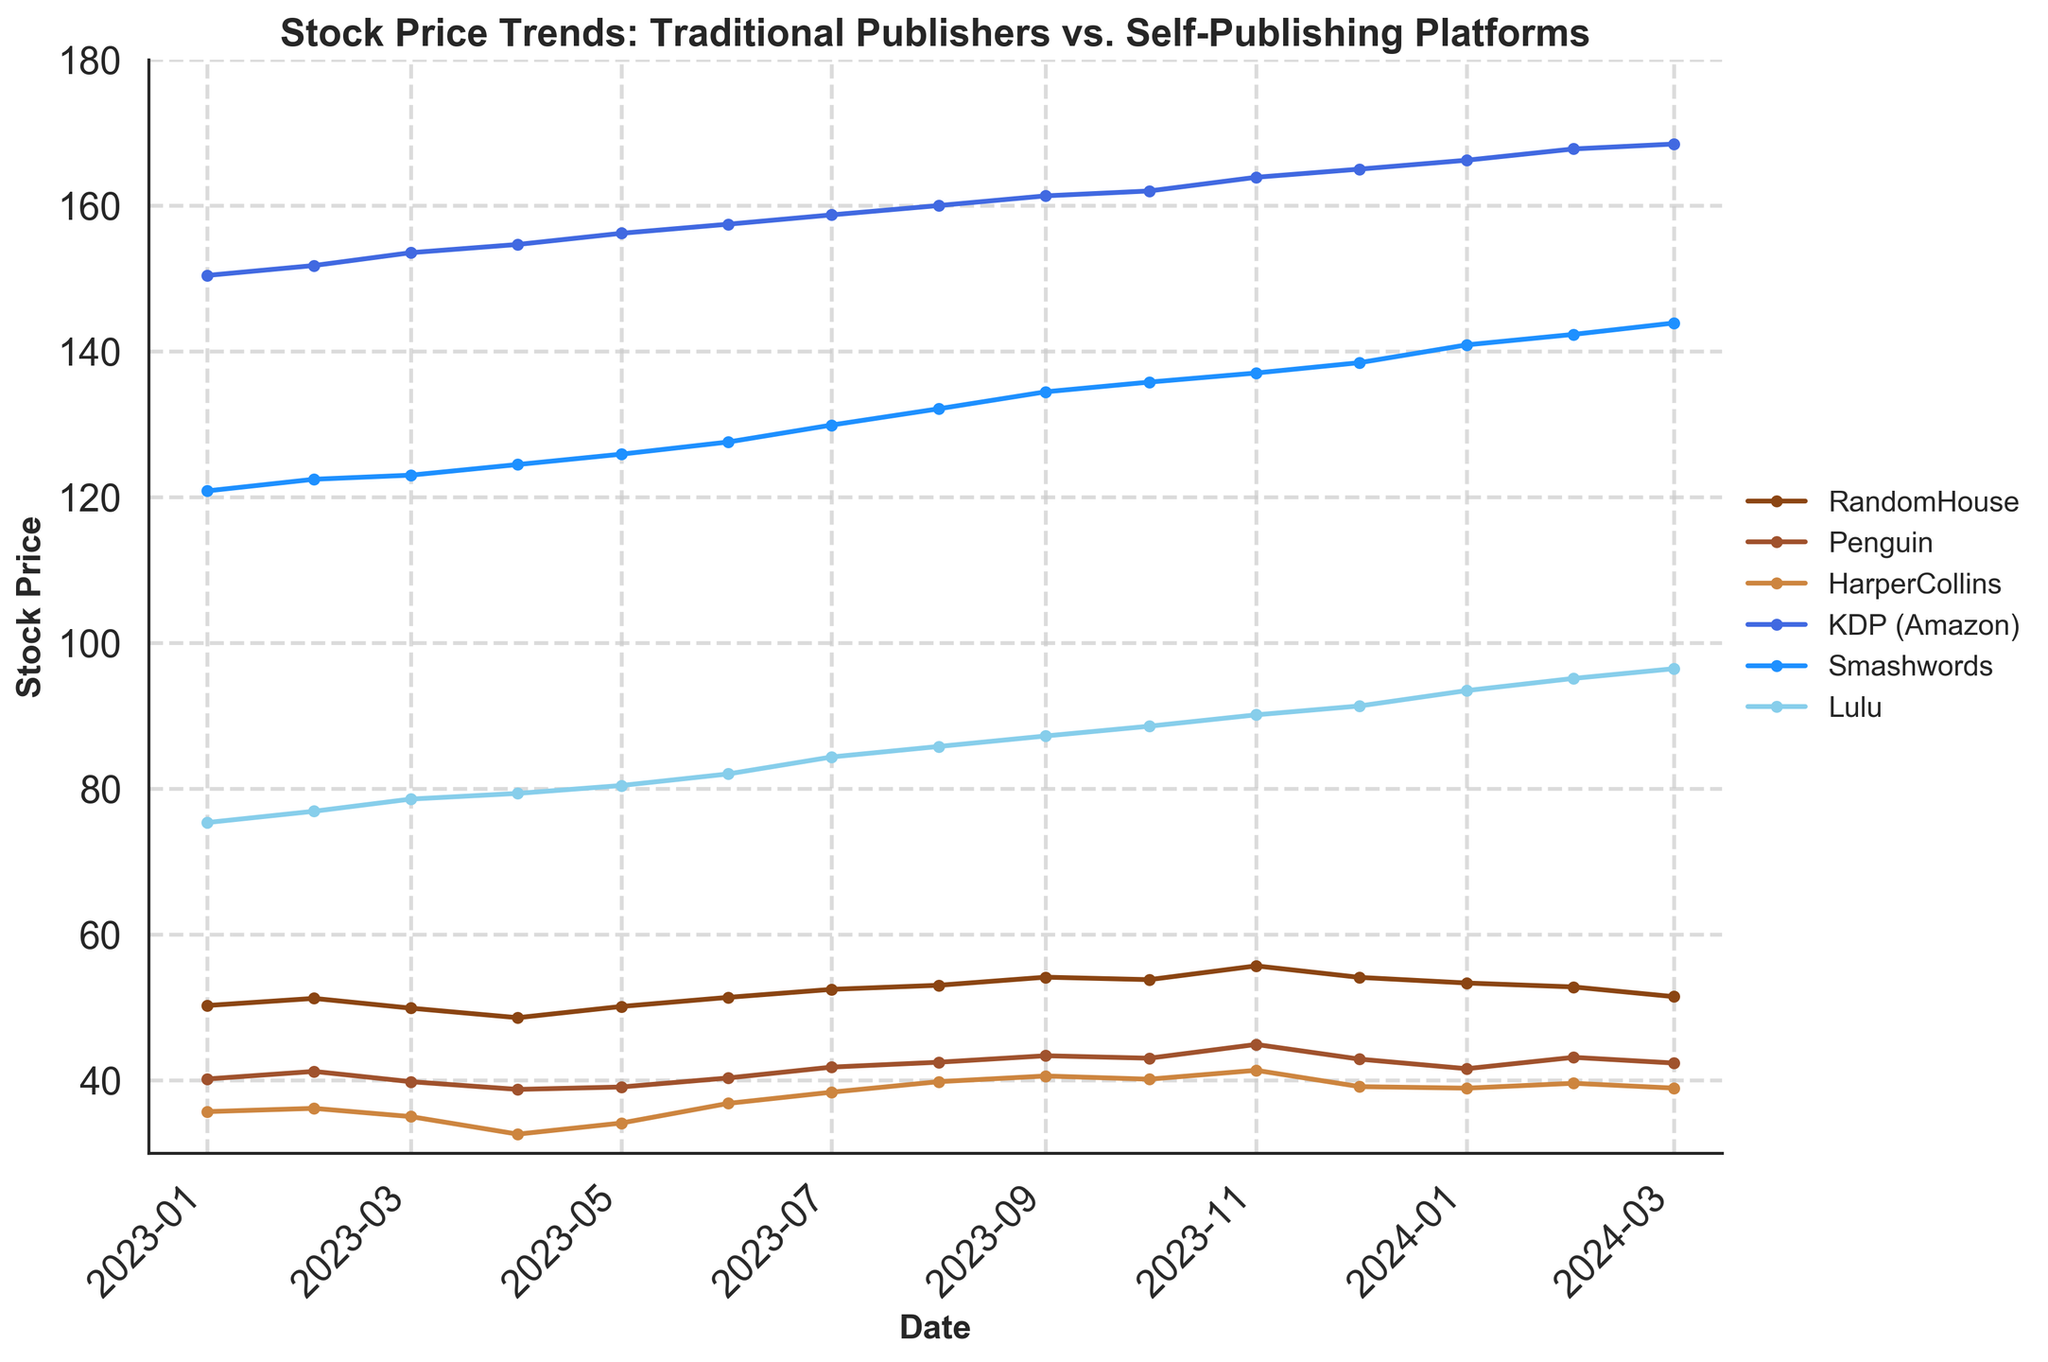What's the title of the plot? The title of the plot is at the top of the chart and provides a summary of what the plot is about.
Answer: Stock Price Trends: Traditional Publishers vs. Self-Publishing Platforms How many companies are represented in the plot? The plot legend on the right side lists all the companies whose stock prices are represented.
Answer: 6 Which company had the highest stock price on 2023-01-01? By examining the y-values of the data points for each company on 2023-01-01, we see that 'KDP (Amazon)' has the highest stock price.
Answer: KDP (Amazon) What general trend is noticeable in the stock prices of 'RandomHouse' and 'Penguin' over the time period? The stock prices for both 'RandomHouse' and 'Penguin' can be seen increasing, which is evident from their series of upward sloping data points.
Answer: Increasing What is the approximate difference in the stock prices of 'HarperCollins' between 2023-03-01 and 2024-03-01? To find the difference, look at the y-values corresponding to these dates and subtract the earlier value from the later one. Stock price on 2023-03-01 is approximately 34.99 and on 2024-03-01 it's about 38.9. So the difference is about 38.9 - 34.99.
Answer: 3.91 Which company had the lowest stock price in 2024-02-01? Checking the y-values of all companies on that date, 'HarperCollins' has the lowest stock price.
Answer: HarperCollins Comparing 'KDP (Amazon)' and 'Smashwords', which company saw a greater increase in stock price from 2023-01-01 to 2024-03-01? Calculate the differences for both companies between the two dates. For 'KDP (Amazon)', it is 168.45 - 150.42 = 18.03. For 'Smashwords', it is 143.89 - 120.85 = 23.04.
Answer: Smashwords Between 'Lulu' and 'Penguin', which company's stock price showed more stability from 2023-01-01 to 2024-03-01? To determine stability, examine the fluctuation or variance of the stock prices. 'Lulu' shows a more consistent upward trend, while 'Penguin' shows minor fluctuations.
Answer: Lulu What is the average stock price of 'RandomHouse' over the first quarter of 2023 (Jan, Feb, Mar)? The monthly stock prices for the first three months are 50.23, 51.21, and 49.87. Calculate the average: (50.23 + 51.21 + 49.87) / 3.
Answer: 50.44 On which month in the plot did 'Penguin' see its highest stock price? By scanning through the y-values for 'Penguin', the highest value appears in the month of November 2023.
Answer: November 2023 